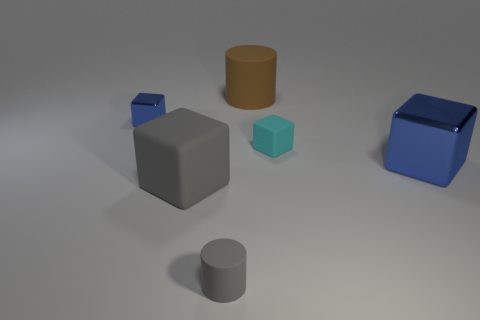Add 3 tiny cyan objects. How many objects exist? 9 Add 5 gray things. How many gray things are left? 7 Add 2 rubber cubes. How many rubber cubes exist? 4 Subtract all brown cylinders. How many cylinders are left? 1 Subtract all big blue shiny cubes. How many cubes are left? 3 Subtract 0 green spheres. How many objects are left? 6 Subtract all cubes. How many objects are left? 2 Subtract 1 cubes. How many cubes are left? 3 Subtract all brown cylinders. Subtract all cyan balls. How many cylinders are left? 1 Subtract all gray cylinders. How many purple blocks are left? 0 